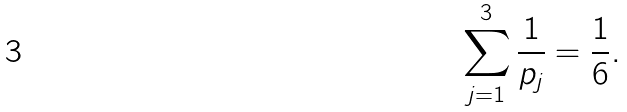<formula> <loc_0><loc_0><loc_500><loc_500>\sum _ { j = 1 } ^ { 3 } \frac { 1 } { p _ { j } } = \frac { 1 } { 6 } .</formula> 